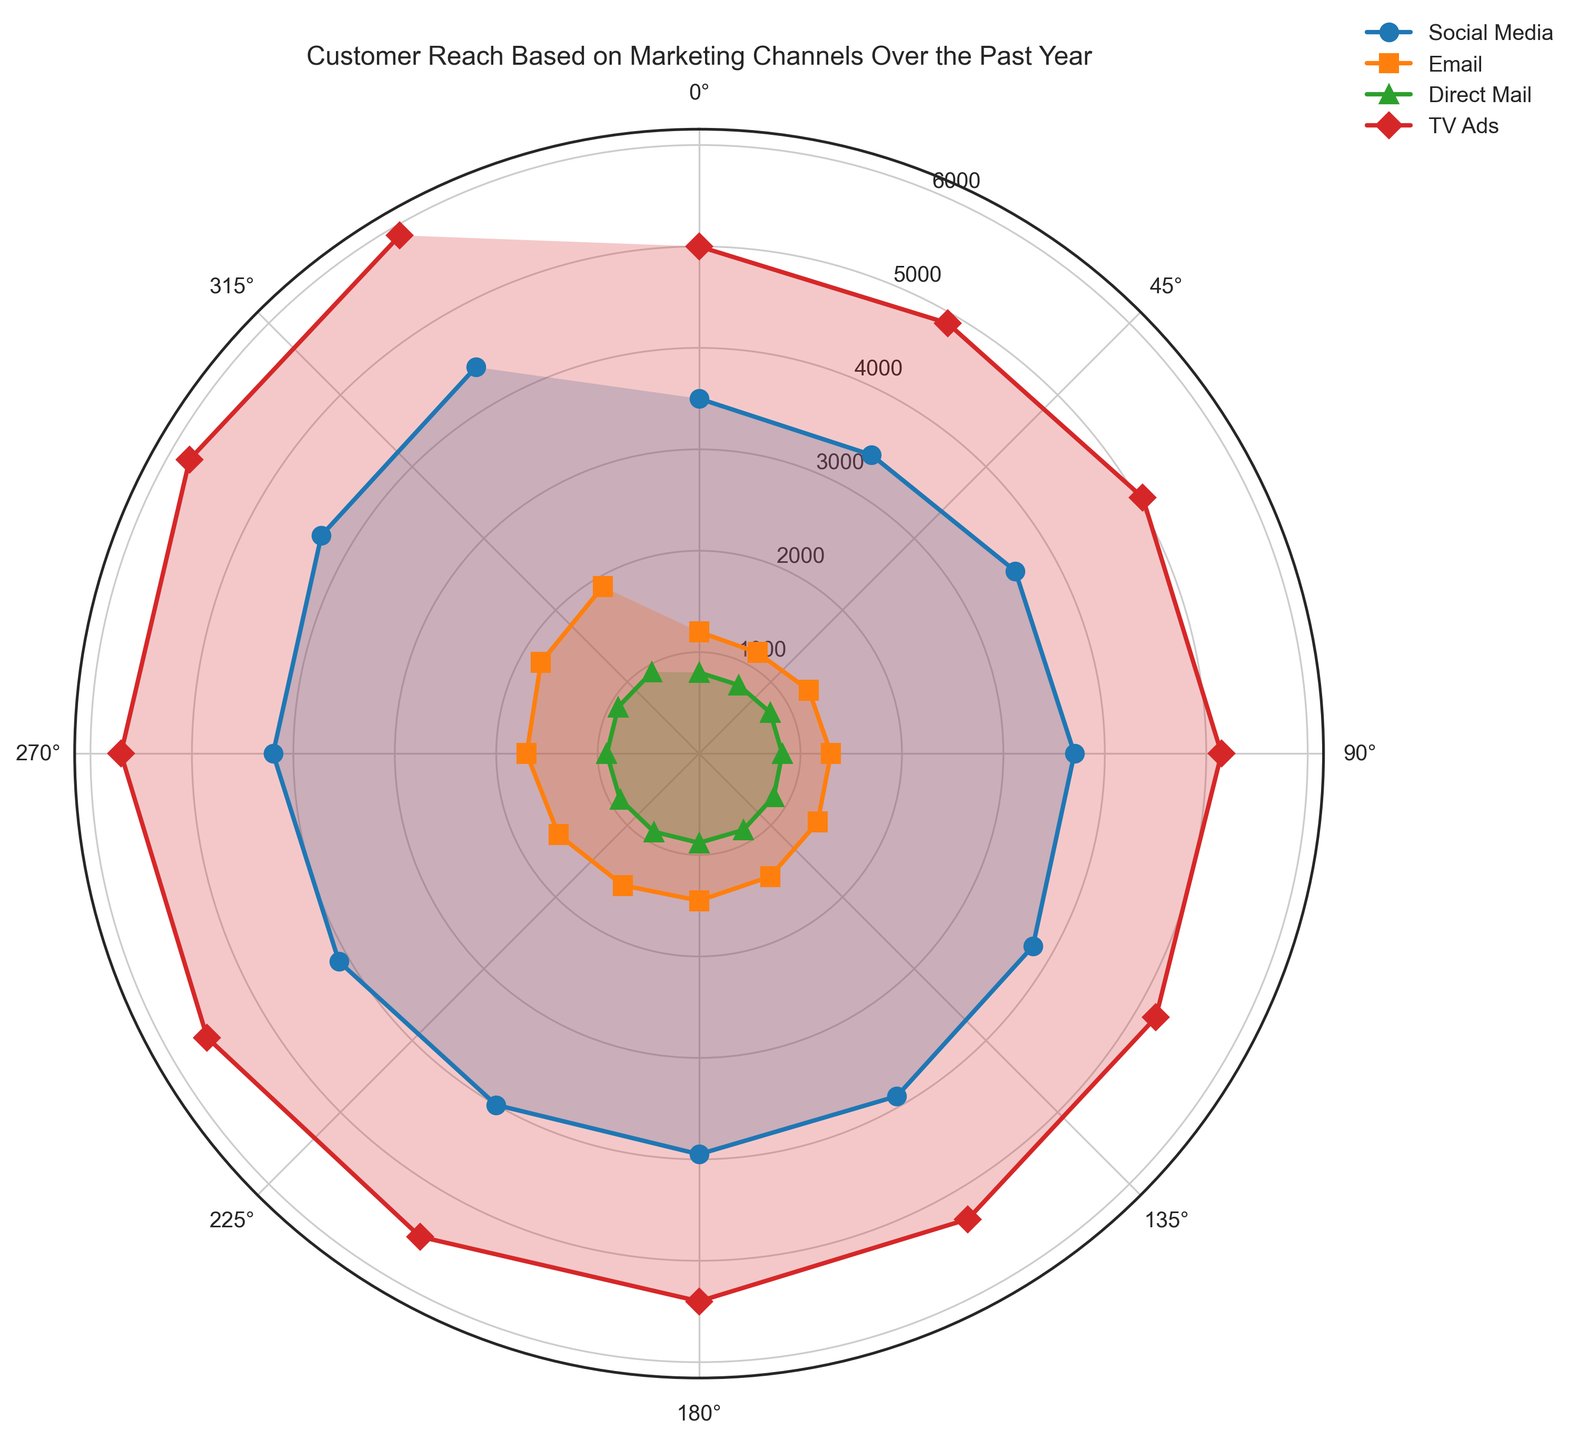What's the peak customer reach for TV Ads? By looking at the plot, identify the month with the highest point for TV Ads and read off the corresponding customer reach value.
Answer: 5900 Which channel had the lowest reach in November? Locate November in the figure, compare the values for all channels in that month, and identify the smallest number.
Answer: Direct Mail How much did Social Media's customer reach increase from January to December? Locate the values for Social Media in January and December, then subtract the January value from the December value (4400 - 3500).
Answer: 900 Which channel had the most consistent customer reach throughout the year? Observe the lines for each channel and determine which has the least variation (i.e., the flattest line).
Answer: Direct Mail In which month did Email achieve its highest customer reach? Identify the highest point on the Email plot and check which month it corresponds to.
Answer: December Compare the customer reach of Direct Mail and Social Media in July. Which was higher and by how much? Look at the values for Direct Mail and Social Media in July, subtract the smaller value from the larger one (3950 - 880).
Answer: Social Media by 3070 What is the average customer reach for TV Ads over the whole year? Sum the values of TV Ads for each month and then divide by 12 (average of: 5000, 4900, 5050, 5150, 5200, 5300, 5400, 5500, 5600, 5700, 5800, 5900).
Answer: 5383 Does any channel other than TV Ads ever reach a monthly customer reach above 5000? Review the plot for all channels except TV Ads and identify any point exceeding 5000.
Answer: No Which month shows the biggest drop in customer reach for Social Media from the previous month? Calculate the month-to-month differences for Social Media and identify the largest negative change.
Answer: February By how much did the customer reach for Email grow from February to October? Subtract the February value from the October value for Email (1700 - 1150).
Answer: 550 